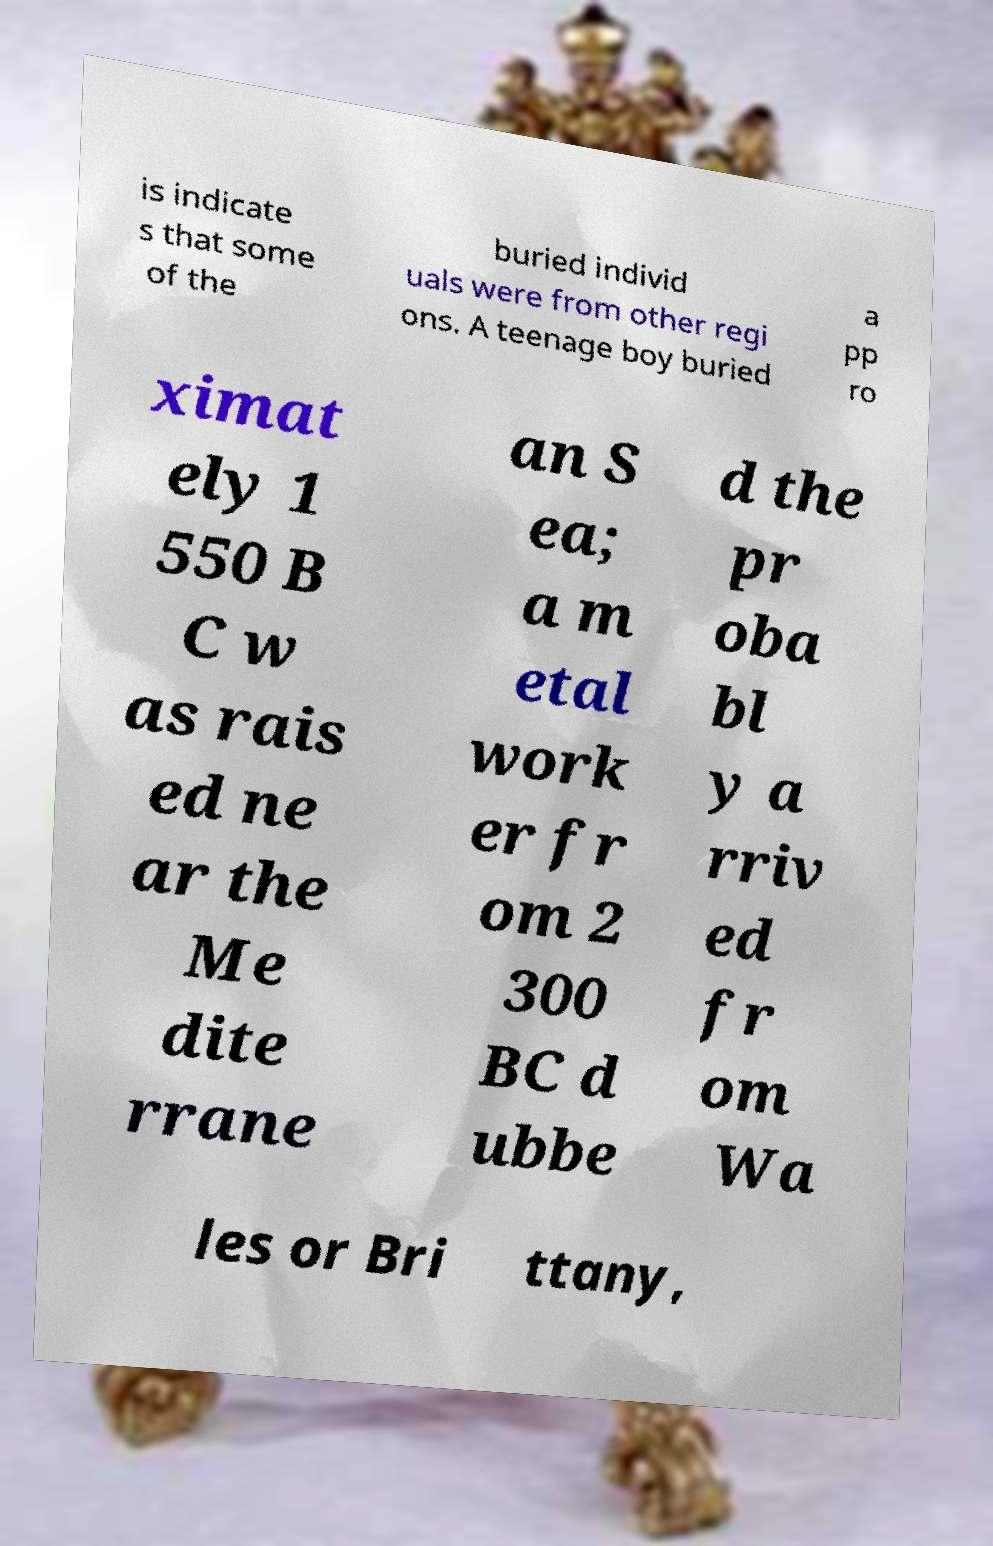I need the written content from this picture converted into text. Can you do that? is indicate s that some of the buried individ uals were from other regi ons. A teenage boy buried a pp ro ximat ely 1 550 B C w as rais ed ne ar the Me dite rrane an S ea; a m etal work er fr om 2 300 BC d ubbe d the pr oba bl y a rriv ed fr om Wa les or Bri ttany, 